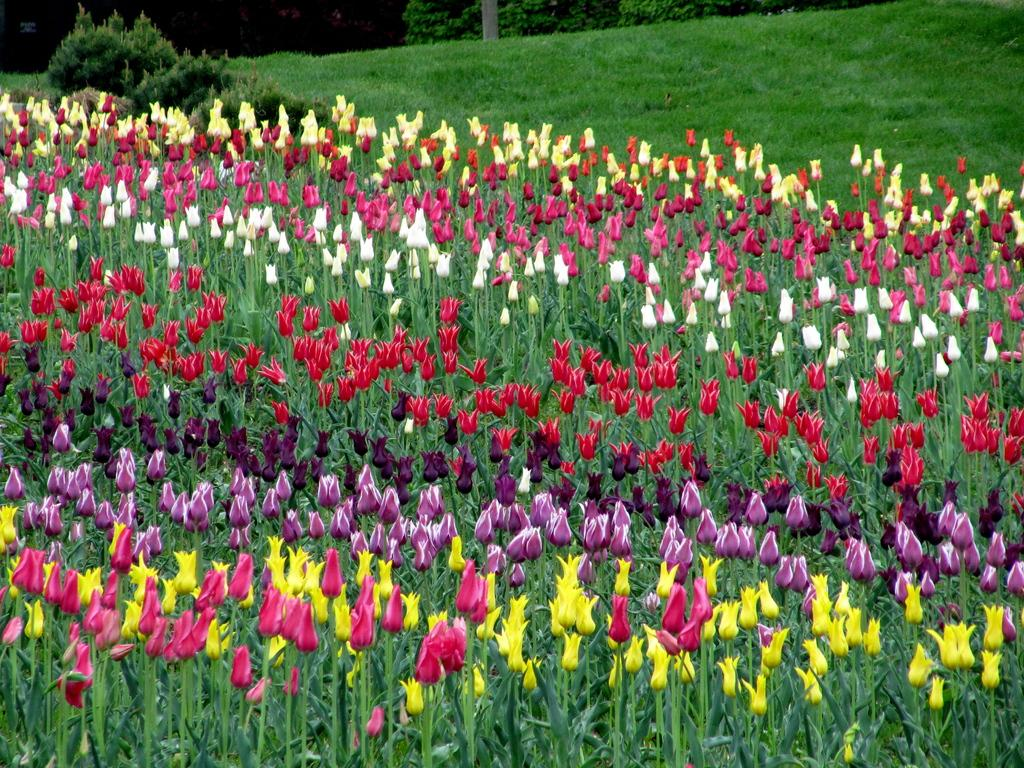What type of vegetation can be seen in the image? Flowers, plants, trees, and grass can be seen in the image. Can you describe the different types of vegetation present in the image? The image contains flowers, plants, trees, and grass. What is the natural environment depicted in the image? The natural environment depicted in the image includes various types of vegetation, such as flowers, plants, trees, and grass. Can you see any wounds on the flowers in the image? There are no wounds visible on the flowers in the image. Is there any snow present in the image? There is no snow present in the image. Are there any fairies visible among the vegetation in the image? There are no fairies visible in the image. 